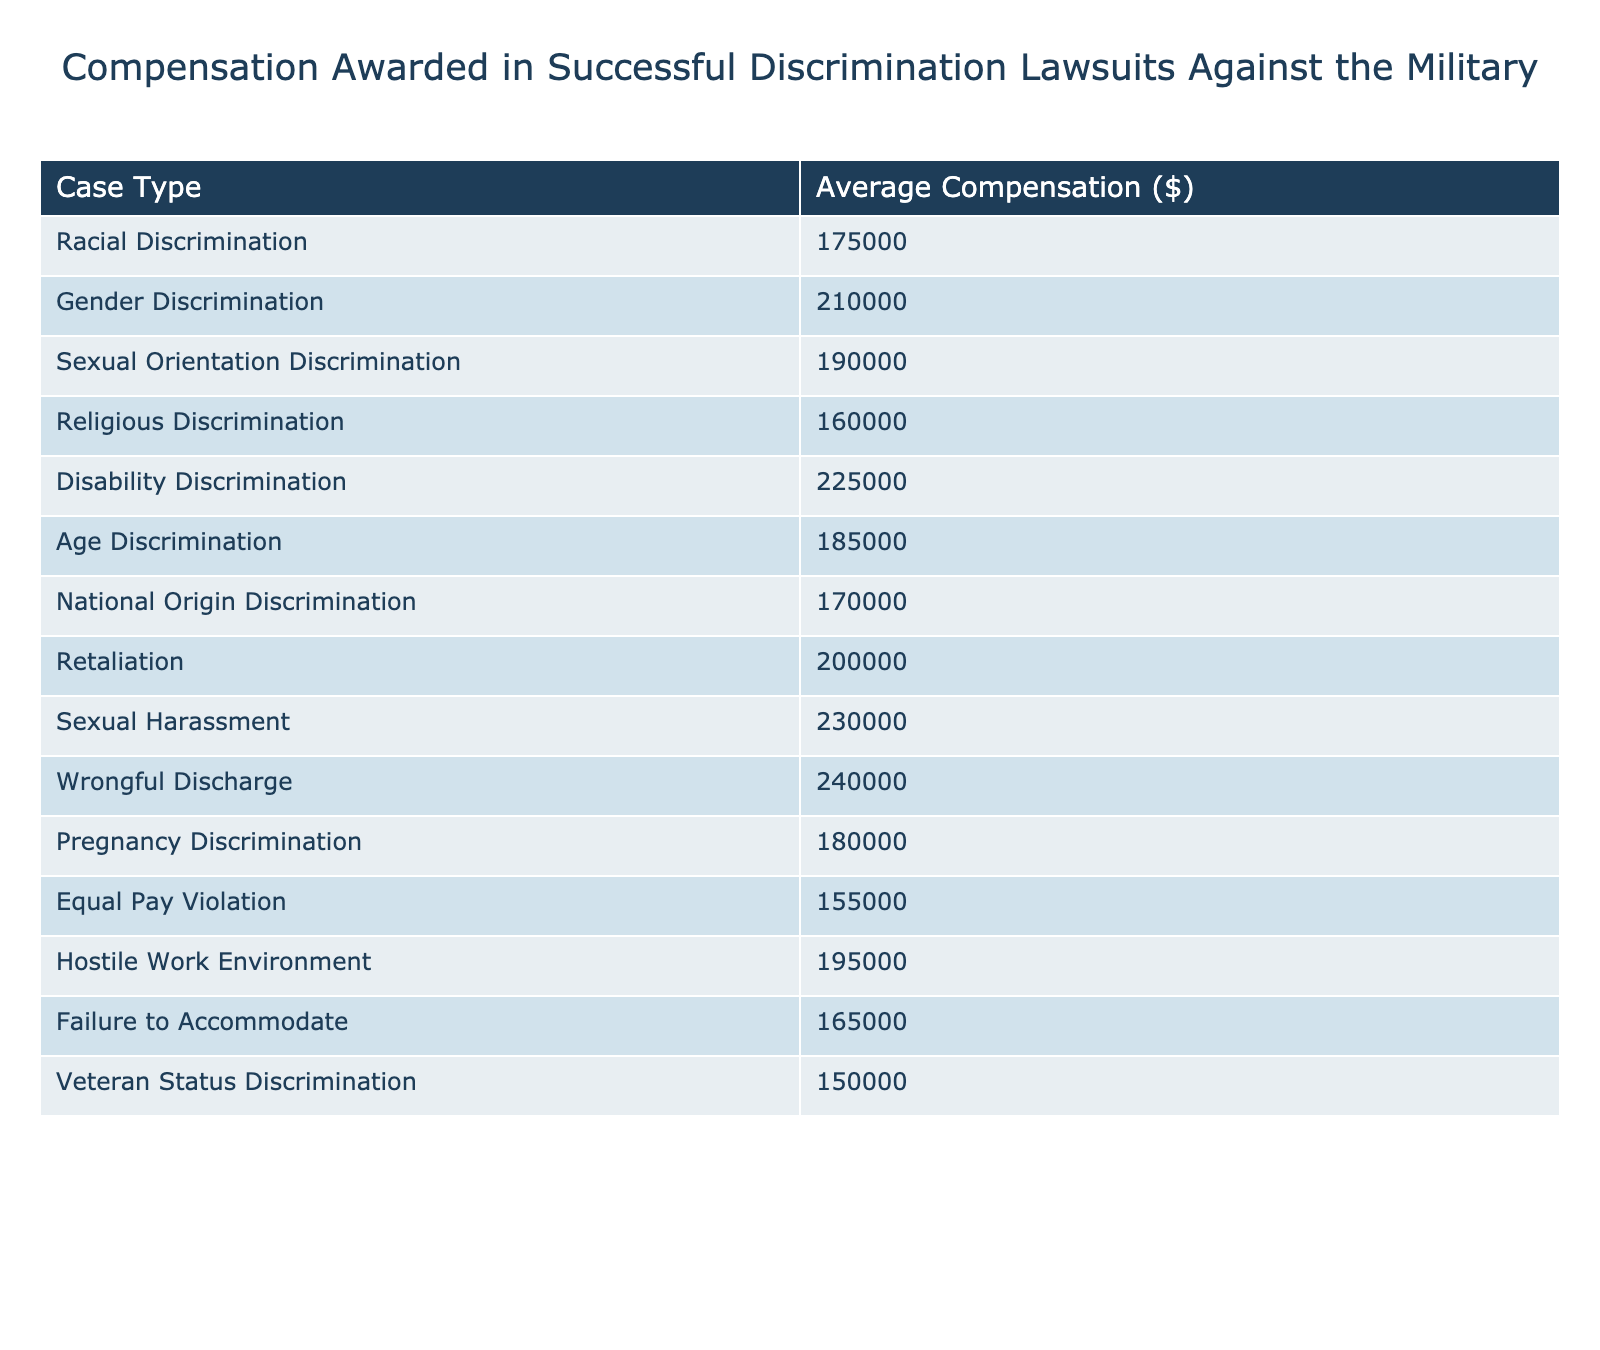What is the average compensation awarded for Gender Discrimination cases? The table shows that the average compensation for Gender Discrimination is listed as $210,000.
Answer: $210,000 Which discrimination case has the highest average compensation? The table indicates that the case type with the highest average compensation is Wrongful Discharge, with an amount of $240,000.
Answer: $240,000 What is the difference in average compensation between Sexual Harassment and Religious Discrimination cases? The average compensation for Sexual Harassment is $230,000, and for Religious Discrimination, it is $160,000. The difference is $230,000 - $160,000 = $70,000.
Answer: $70,000 Is the average compensation for Disability Discrimination higher than that for National Origin Discrimination? Disability Discrimination has an average compensation of $225,000, while National Origin Discrimination has $170,000. Since $225,000 is greater than $170,000, the statement is true.
Answer: Yes What is the average compensation for all cases listed in the table? To find the average, we sum up all the average compensations: 175000 + 210000 + 190000 + 160000 + 225000 + 185000 + 170000 + 200000 + 230000 + 240000 + 180000 + 155000 + 195000 + 165000 + 150000 = 2,730,000. Then divide by the number of cases, which is 15: 2,730,000 / 15 = 182,000.
Answer: $182,000 Which case type has the lowest average compensation awarded? By observing the table data, it shows that the case with the lowest average compensation is Veteran Status Discrimination, with an average of $150,000.
Answer: $150,000 How much more compensation is awarded on average for Sexual Harassment than for Equal Pay Violations? The average for Sexual Harassment is $230,000 and for Equal Pay Violations it is $155,000. The difference is $230,000 - $155,000 = $75,000.
Answer: $75,000 Find the median compensation amount among the listed case types. First, we arrange the average compensation amounts in ascending order: 150000, 155000, 160000, 165000, 170000, 175000, 180000, 185000, 190000, 195000, 200000, 210000, 225000, 230000, 240000. Since there are 15 data points, the median is the 8th value, which is $185,000.
Answer: $185,000 Are there more cases with an average compensation higher than $200,000 or lower than $200,000? The cases above $200,000 are: Sexual Harassment, Wrongful Discharge, and Disability Discrimination (3 cases), while below are: Racial, Gender, Religious, Age, National Origin, Pregnancy, Equal Pay, Hostile Work Environment, Failure to Accommodate, and Veteran Status Discrimination (12 cases). Thus, there are more cases below $200,000.
Answer: Lower than $200,000 What is the sum of average compensations for Racial and Age Discrimination? The average for Racial Discrimination is $175,000, and for Age Discrimination is $185,000. The sum is $175,000 + $185,000 = $360,000.
Answer: $360,000 Which case types have an average compensation under $170,000? The table shows that the case types with average compensations below $170,000 are Veteran Status Discrimination ($150,000) and Equal Pay Violation ($155,000).
Answer: Veteran Status Discrimination and Equal Pay Violation 